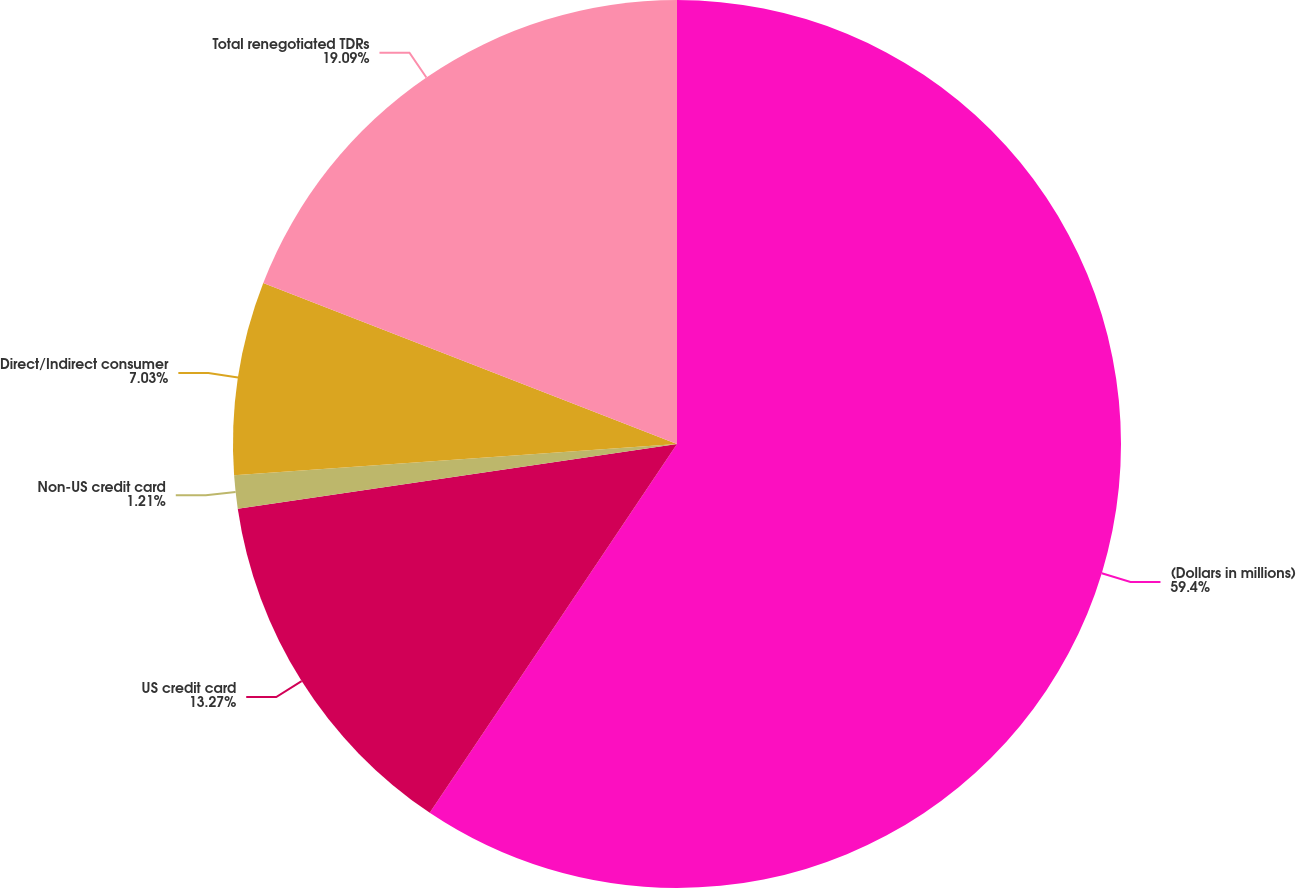Convert chart. <chart><loc_0><loc_0><loc_500><loc_500><pie_chart><fcel>(Dollars in millions)<fcel>US credit card<fcel>Non-US credit card<fcel>Direct/Indirect consumer<fcel>Total renegotiated TDRs<nl><fcel>59.4%<fcel>13.27%<fcel>1.21%<fcel>7.03%<fcel>19.09%<nl></chart> 